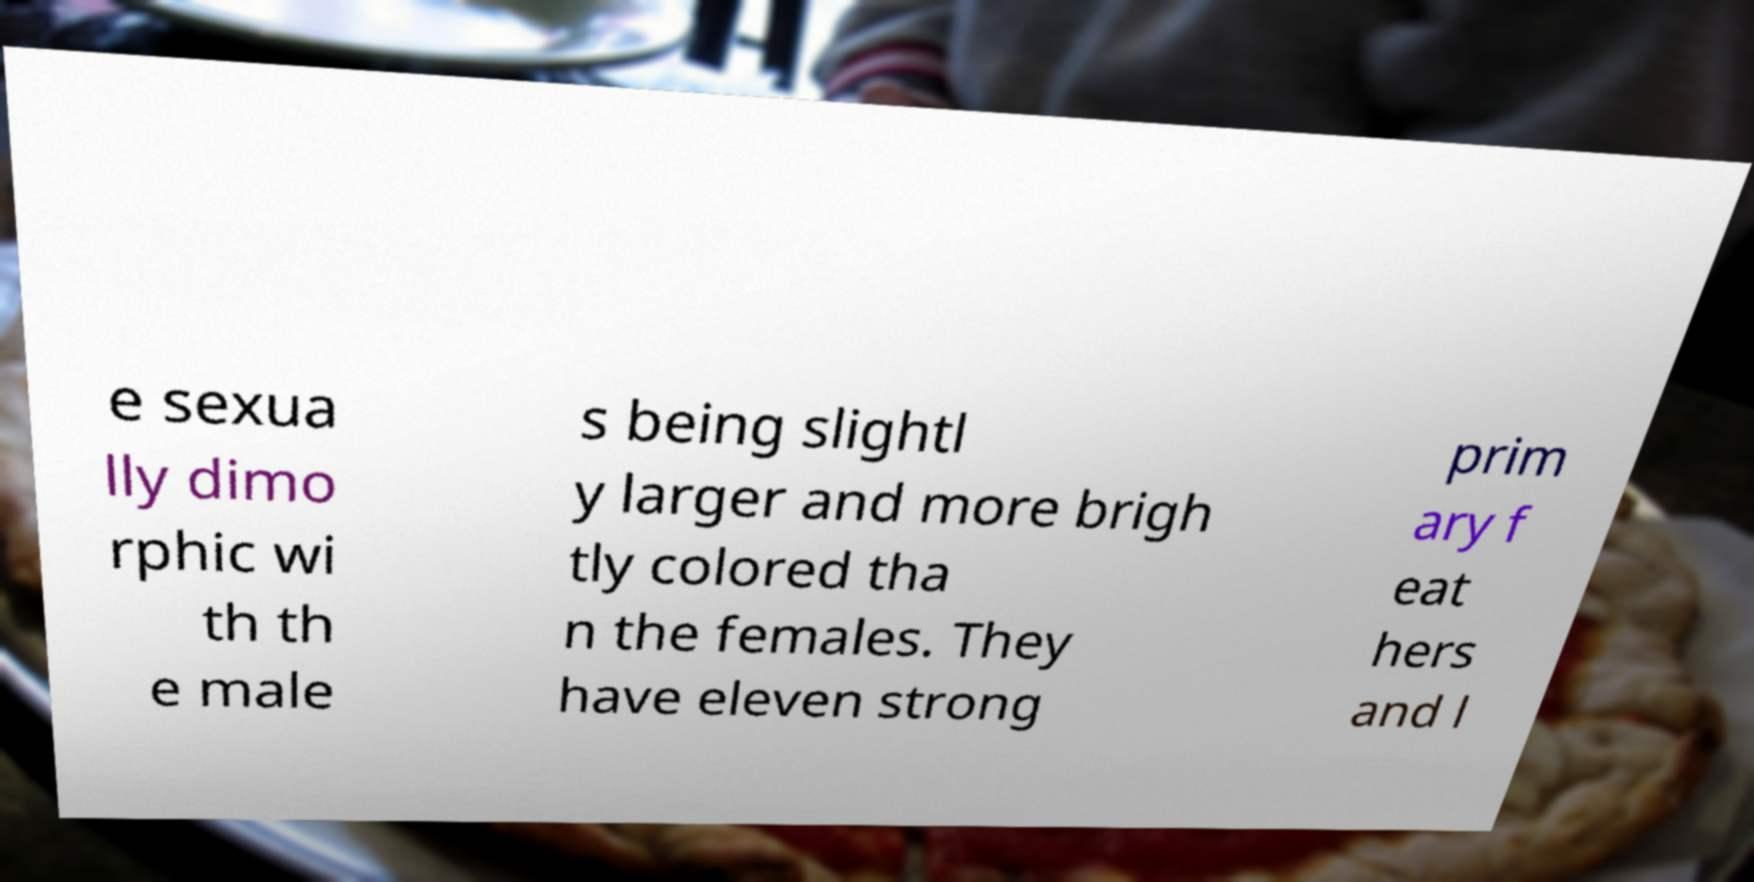Could you assist in decoding the text presented in this image and type it out clearly? e sexua lly dimo rphic wi th th e male s being slightl y larger and more brigh tly colored tha n the females. They have eleven strong prim ary f eat hers and l 